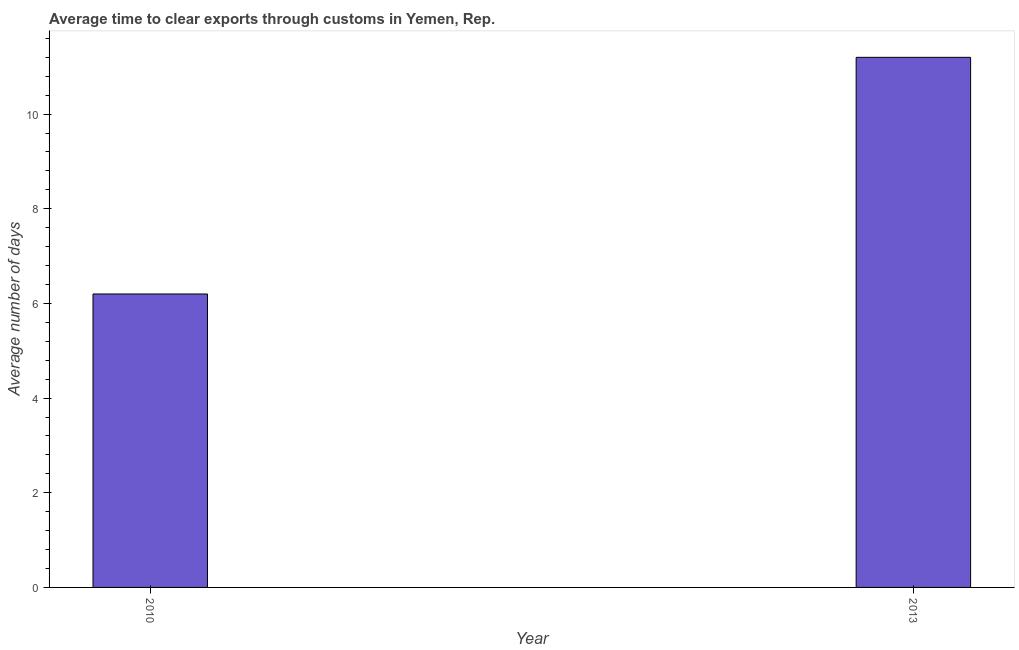What is the title of the graph?
Provide a short and direct response. Average time to clear exports through customs in Yemen, Rep. What is the label or title of the X-axis?
Your answer should be very brief. Year. What is the label or title of the Y-axis?
Offer a terse response. Average number of days. Across all years, what is the maximum time to clear exports through customs?
Keep it short and to the point. 11.2. In which year was the time to clear exports through customs minimum?
Offer a very short reply. 2010. What is the sum of the time to clear exports through customs?
Your answer should be very brief. 17.4. What is the average time to clear exports through customs per year?
Your response must be concise. 8.7. What is the median time to clear exports through customs?
Offer a terse response. 8.7. What is the ratio of the time to clear exports through customs in 2010 to that in 2013?
Provide a short and direct response. 0.55. Is the time to clear exports through customs in 2010 less than that in 2013?
Offer a very short reply. Yes. What is the Average number of days of 2013?
Your response must be concise. 11.2. What is the difference between the Average number of days in 2010 and 2013?
Give a very brief answer. -5. What is the ratio of the Average number of days in 2010 to that in 2013?
Offer a very short reply. 0.55. 